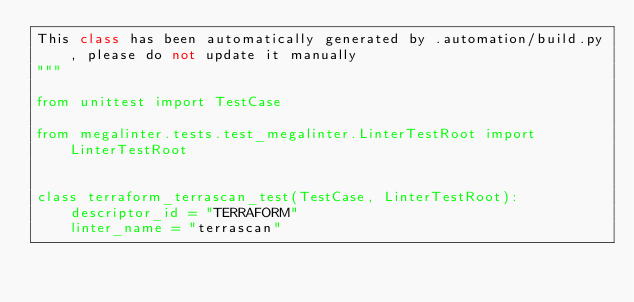Convert code to text. <code><loc_0><loc_0><loc_500><loc_500><_Python_>This class has been automatically generated by .automation/build.py, please do not update it manually
"""

from unittest import TestCase

from megalinter.tests.test_megalinter.LinterTestRoot import LinterTestRoot


class terraform_terrascan_test(TestCase, LinterTestRoot):
    descriptor_id = "TERRAFORM"
    linter_name = "terrascan"
</code> 